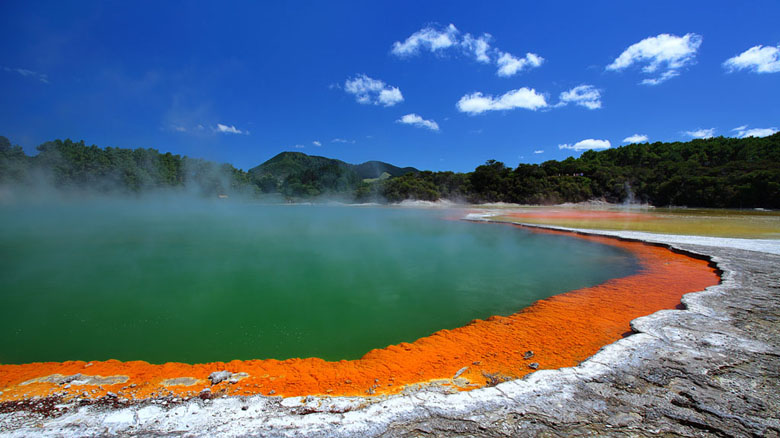Share a detailed travel guide entry for this location. Welcome to Wai-O-Tapu Thermal Wonderland, one of New Zealand's most vibrant and unique geothermal attractions located in Rotorua. This geothermal area is renowned for its colorful hot springs, otherworldly landscapes, and impressive geothermal activity. Here’s a detailed guide to help you explore this spectacular destination:

**Getting There:**
Wai-O-Tapu Thermal Wonderland is situated about 27 kilometers south of Rotorua city center. You can reach the site by car, with ample parking available on the premises. Alternatively, you can book a guided tour from Rotorura, which often includes transportation.

**Opening Hours and Admission:**
The park is open daily from 8:30 AM to 5:00 PM, with the last admission at 3:45 PM. It's recommended to arrive early to enjoy the full experience. Admission fees apply, so be sure to check their official website for the latest pricing and any seasonal variations.

**Key Attractions:**
- **Champagne Pool:** This is the star attraction, a large hot spring with vivid orange and green hues due to mineral deposits and thermophilic microorganisms. The hot waters and rising steam make for a dramatic and mesmerizing sight.
- **Lady Knox Geyser:** Erupting daily at 10:15 AM, this geyser reaches heights of up to 20 meters. Don’t miss this unique natural display!
- **Mud Pools:** These bubbling, boiling mud pools provide a fascinating glimpse into the geothermal activity beneath the surface. They are particularly captivating when the mud bubbles and splashes.
- **Artist's Palette:** This area is notable for its colorful mineral deposits that create a stunning array of colors on the ground, reminiscent of an artist’s palette.

**Facilities:**
Wai-O-Tapu Thermal Wonderland offers various amenities for visitors, including a café, restrooms, and a gift shop where you can purchase souvenirs and geological specimens. Informational signs and guided tours are available to enhance your understanding of the geothermal features.

**Tips for Visitors:**
- **Wear comfortable walking shoes:** The park has well-marked walking trails, but some areas may be uneven or slippery due to geothermal activity.
- **Stay on designated paths:** For safety, it's crucial to follow the marked paths and avoid venturing too close to the hot springs and geysers.
- **Photography:** Bring your camera or smartphone to capture the stunning scenery. Morning light can provide the best photography conditions.
- **Stay hydrated and wear sunscreen:** The geothermal area can be hot, and there is limited shade along the trails.

**Local Recommendations:**
After exploring Wai-O-Tapu, consider visiting nearby attractions such as the Waimangu Volcanic Valley or relaxing in one of Rotorua’s natural hot springs. The city itself offers a rich Maori cultural experience, with performances, traditional feasts, and cultural centers to visit.

Wai-O-Tapu Thermal Wonderland is a must-visit for anyone traveling to New Zealand. Its extraordinary geothermal landscape is a testament to the Earth’s raw natural beauty and geothermal activity, offering an experience that is both educational and awe-inspiring. 